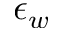Convert formula to latex. <formula><loc_0><loc_0><loc_500><loc_500>\epsilon _ { w }</formula> 